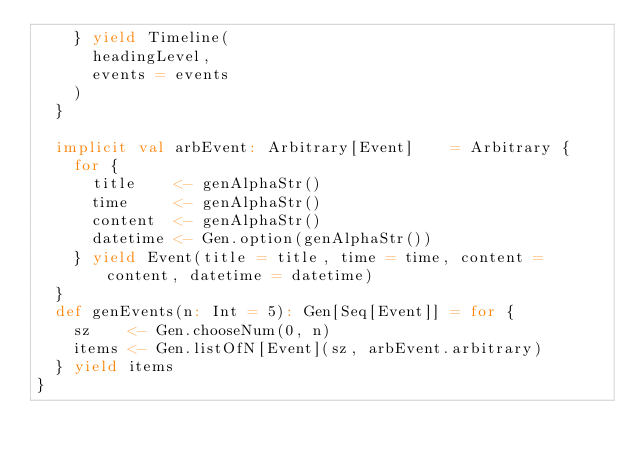Convert code to text. <code><loc_0><loc_0><loc_500><loc_500><_Scala_>    } yield Timeline(
      headingLevel,
      events = events
    )
  }

  implicit val arbEvent: Arbitrary[Event]    = Arbitrary {
    for {
      title    <- genAlphaStr()
      time     <- genAlphaStr()
      content  <- genAlphaStr()
      datetime <- Gen.option(genAlphaStr())
    } yield Event(title = title, time = time, content = content, datetime = datetime)
  }
  def genEvents(n: Int = 5): Gen[Seq[Event]] = for {
    sz    <- Gen.chooseNum(0, n)
    items <- Gen.listOfN[Event](sz, arbEvent.arbitrary)
  } yield items
}
</code> 